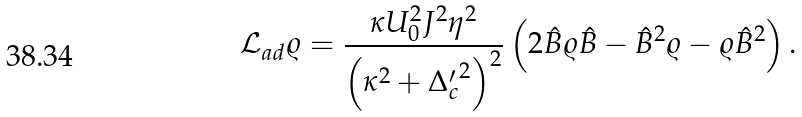Convert formula to latex. <formula><loc_0><loc_0><loc_500><loc_500>\mathcal { L } _ { a d } \varrho = \frac { \kappa U _ { 0 } ^ { 2 } J ^ { 2 } \eta ^ { 2 } } { \left ( \kappa ^ { 2 } + { \Delta _ { c } ^ { \prime } } ^ { 2 } \right ) ^ { 2 } } \left ( 2 \hat { B } \varrho \hat { B } - \hat { B } ^ { 2 } \varrho - \varrho \hat { B } ^ { 2 } \right ) .</formula> 